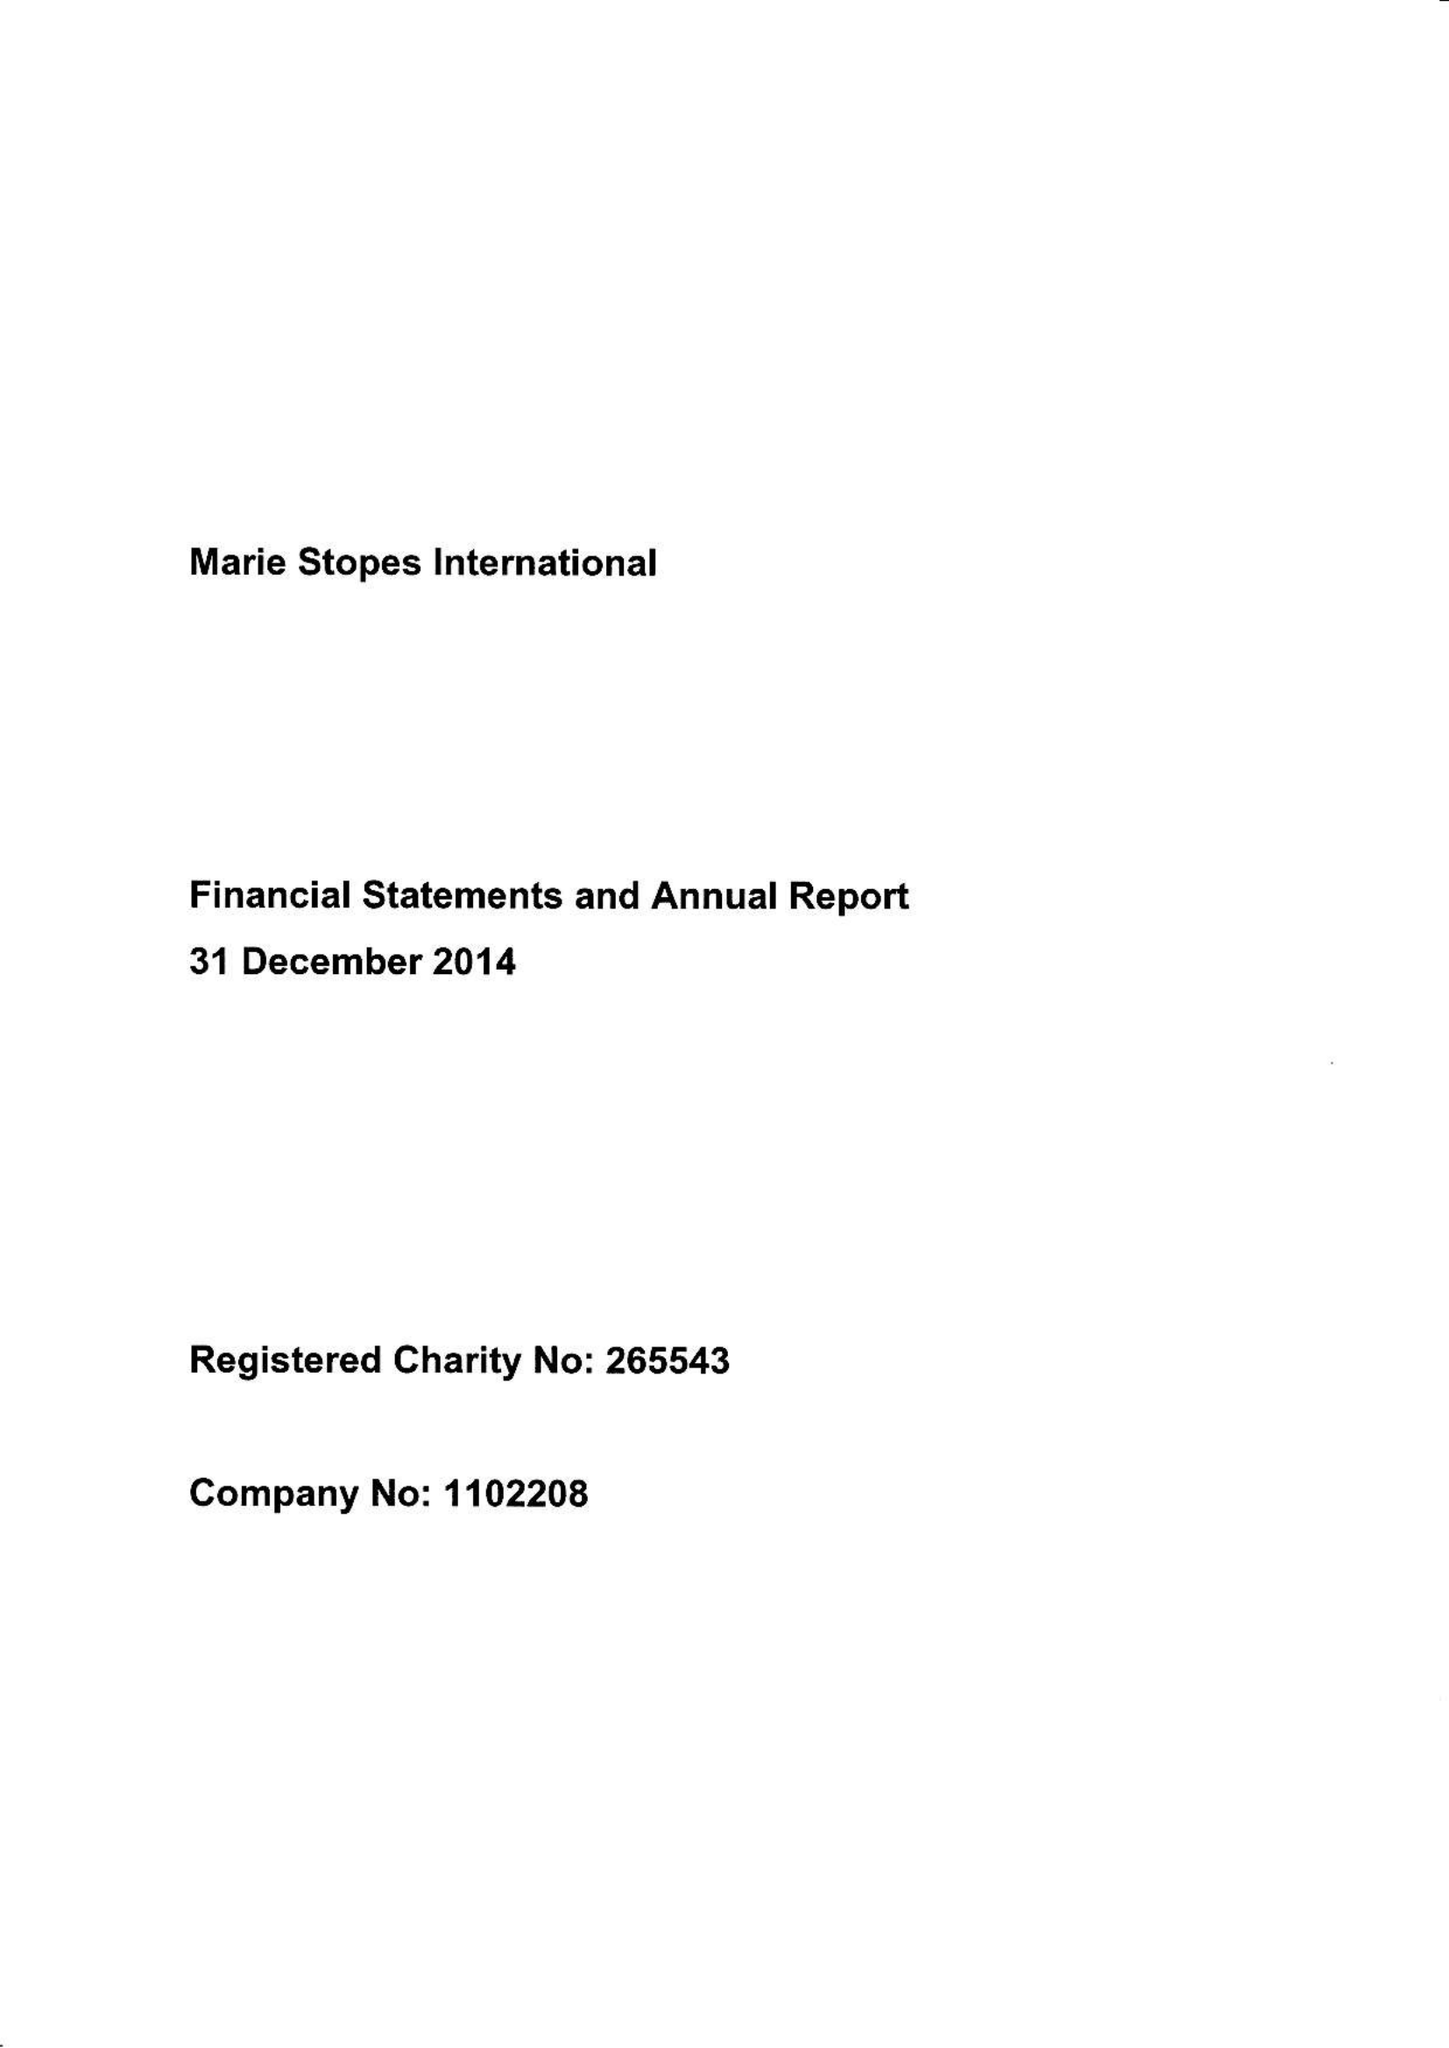What is the value for the address__postcode?
Answer the question using a single word or phrase. W1T 6LP 